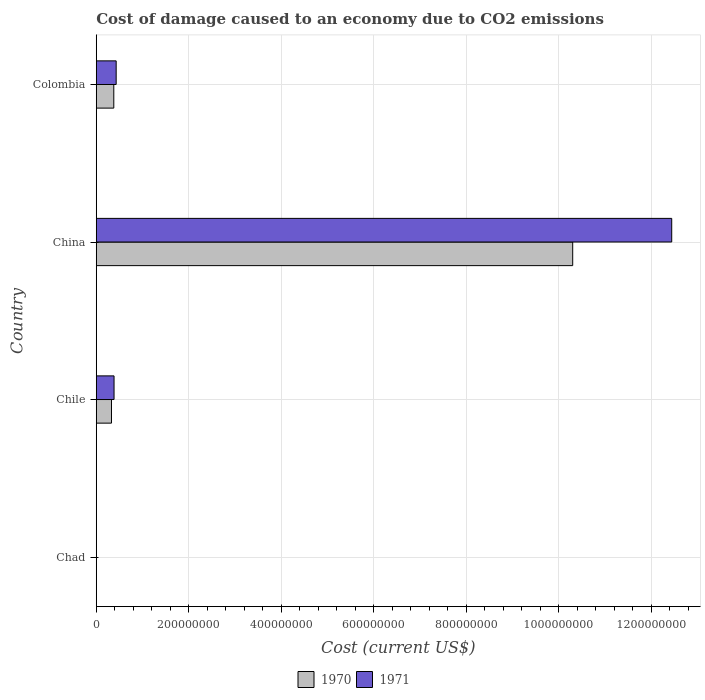How many bars are there on the 2nd tick from the bottom?
Provide a short and direct response. 2. What is the label of the 2nd group of bars from the top?
Make the answer very short. China. In how many cases, is the number of bars for a given country not equal to the number of legend labels?
Your answer should be very brief. 0. What is the cost of damage caused due to CO2 emissisons in 1971 in China?
Provide a succinct answer. 1.24e+09. Across all countries, what is the maximum cost of damage caused due to CO2 emissisons in 1970?
Your response must be concise. 1.03e+09. Across all countries, what is the minimum cost of damage caused due to CO2 emissisons in 1971?
Offer a terse response. 2.13e+05. In which country was the cost of damage caused due to CO2 emissisons in 1971 minimum?
Give a very brief answer. Chad. What is the total cost of damage caused due to CO2 emissisons in 1970 in the graph?
Your answer should be very brief. 1.10e+09. What is the difference between the cost of damage caused due to CO2 emissisons in 1971 in Chad and that in Chile?
Your response must be concise. -3.82e+07. What is the difference between the cost of damage caused due to CO2 emissisons in 1970 in Colombia and the cost of damage caused due to CO2 emissisons in 1971 in China?
Ensure brevity in your answer.  -1.21e+09. What is the average cost of damage caused due to CO2 emissisons in 1970 per country?
Provide a succinct answer. 2.75e+08. What is the difference between the cost of damage caused due to CO2 emissisons in 1970 and cost of damage caused due to CO2 emissisons in 1971 in Chile?
Give a very brief answer. -5.53e+06. In how many countries, is the cost of damage caused due to CO2 emissisons in 1971 greater than 40000000 US$?
Ensure brevity in your answer.  2. What is the ratio of the cost of damage caused due to CO2 emissisons in 1971 in Chad to that in Colombia?
Ensure brevity in your answer.  0. Is the cost of damage caused due to CO2 emissisons in 1970 in Chile less than that in Colombia?
Ensure brevity in your answer.  Yes. Is the difference between the cost of damage caused due to CO2 emissisons in 1970 in China and Colombia greater than the difference between the cost of damage caused due to CO2 emissisons in 1971 in China and Colombia?
Ensure brevity in your answer.  No. What is the difference between the highest and the second highest cost of damage caused due to CO2 emissisons in 1970?
Your answer should be compact. 9.92e+08. What is the difference between the highest and the lowest cost of damage caused due to CO2 emissisons in 1970?
Offer a very short reply. 1.03e+09. What does the 2nd bar from the top in Colombia represents?
Offer a very short reply. 1970. What does the 2nd bar from the bottom in China represents?
Offer a very short reply. 1971. How many countries are there in the graph?
Provide a short and direct response. 4. What is the difference between two consecutive major ticks on the X-axis?
Your response must be concise. 2.00e+08. Does the graph contain any zero values?
Ensure brevity in your answer.  No. Does the graph contain grids?
Keep it short and to the point. Yes. How many legend labels are there?
Ensure brevity in your answer.  2. What is the title of the graph?
Offer a terse response. Cost of damage caused to an economy due to CO2 emissions. What is the label or title of the X-axis?
Provide a short and direct response. Cost (current US$). What is the Cost (current US$) in 1970 in Chad?
Your answer should be very brief. 1.66e+05. What is the Cost (current US$) of 1971 in Chad?
Your answer should be very brief. 2.13e+05. What is the Cost (current US$) in 1970 in Chile?
Make the answer very short. 3.29e+07. What is the Cost (current US$) in 1971 in Chile?
Your answer should be very brief. 3.84e+07. What is the Cost (current US$) of 1970 in China?
Offer a very short reply. 1.03e+09. What is the Cost (current US$) in 1971 in China?
Make the answer very short. 1.24e+09. What is the Cost (current US$) in 1970 in Colombia?
Your response must be concise. 3.79e+07. What is the Cost (current US$) in 1971 in Colombia?
Give a very brief answer. 4.30e+07. Across all countries, what is the maximum Cost (current US$) of 1970?
Your response must be concise. 1.03e+09. Across all countries, what is the maximum Cost (current US$) in 1971?
Provide a short and direct response. 1.24e+09. Across all countries, what is the minimum Cost (current US$) in 1970?
Your response must be concise. 1.66e+05. Across all countries, what is the minimum Cost (current US$) of 1971?
Make the answer very short. 2.13e+05. What is the total Cost (current US$) of 1970 in the graph?
Your answer should be compact. 1.10e+09. What is the total Cost (current US$) of 1971 in the graph?
Your answer should be compact. 1.33e+09. What is the difference between the Cost (current US$) in 1970 in Chad and that in Chile?
Provide a short and direct response. -3.28e+07. What is the difference between the Cost (current US$) of 1971 in Chad and that in Chile?
Give a very brief answer. -3.82e+07. What is the difference between the Cost (current US$) in 1970 in Chad and that in China?
Your answer should be very brief. -1.03e+09. What is the difference between the Cost (current US$) of 1971 in Chad and that in China?
Offer a very short reply. -1.24e+09. What is the difference between the Cost (current US$) of 1970 in Chad and that in Colombia?
Ensure brevity in your answer.  -3.77e+07. What is the difference between the Cost (current US$) in 1971 in Chad and that in Colombia?
Ensure brevity in your answer.  -4.28e+07. What is the difference between the Cost (current US$) in 1970 in Chile and that in China?
Your answer should be very brief. -9.97e+08. What is the difference between the Cost (current US$) of 1971 in Chile and that in China?
Your answer should be very brief. -1.21e+09. What is the difference between the Cost (current US$) of 1970 in Chile and that in Colombia?
Offer a very short reply. -4.99e+06. What is the difference between the Cost (current US$) of 1971 in Chile and that in Colombia?
Give a very brief answer. -4.58e+06. What is the difference between the Cost (current US$) of 1970 in China and that in Colombia?
Keep it short and to the point. 9.92e+08. What is the difference between the Cost (current US$) in 1971 in China and that in Colombia?
Ensure brevity in your answer.  1.20e+09. What is the difference between the Cost (current US$) of 1970 in Chad and the Cost (current US$) of 1971 in Chile?
Keep it short and to the point. -3.83e+07. What is the difference between the Cost (current US$) in 1970 in Chad and the Cost (current US$) in 1971 in China?
Ensure brevity in your answer.  -1.24e+09. What is the difference between the Cost (current US$) of 1970 in Chad and the Cost (current US$) of 1971 in Colombia?
Your response must be concise. -4.29e+07. What is the difference between the Cost (current US$) of 1970 in Chile and the Cost (current US$) of 1971 in China?
Provide a short and direct response. -1.21e+09. What is the difference between the Cost (current US$) of 1970 in Chile and the Cost (current US$) of 1971 in Colombia?
Provide a succinct answer. -1.01e+07. What is the difference between the Cost (current US$) in 1970 in China and the Cost (current US$) in 1971 in Colombia?
Provide a succinct answer. 9.87e+08. What is the average Cost (current US$) of 1970 per country?
Keep it short and to the point. 2.75e+08. What is the average Cost (current US$) of 1971 per country?
Keep it short and to the point. 3.31e+08. What is the difference between the Cost (current US$) of 1970 and Cost (current US$) of 1971 in Chad?
Your answer should be compact. -4.69e+04. What is the difference between the Cost (current US$) of 1970 and Cost (current US$) of 1971 in Chile?
Your response must be concise. -5.53e+06. What is the difference between the Cost (current US$) in 1970 and Cost (current US$) in 1971 in China?
Make the answer very short. -2.14e+08. What is the difference between the Cost (current US$) of 1970 and Cost (current US$) of 1971 in Colombia?
Your answer should be compact. -5.12e+06. What is the ratio of the Cost (current US$) of 1970 in Chad to that in Chile?
Your answer should be compact. 0.01. What is the ratio of the Cost (current US$) of 1971 in Chad to that in Chile?
Your response must be concise. 0.01. What is the ratio of the Cost (current US$) of 1970 in Chad to that in Colombia?
Keep it short and to the point. 0. What is the ratio of the Cost (current US$) of 1971 in Chad to that in Colombia?
Keep it short and to the point. 0.01. What is the ratio of the Cost (current US$) of 1970 in Chile to that in China?
Your response must be concise. 0.03. What is the ratio of the Cost (current US$) in 1971 in Chile to that in China?
Provide a succinct answer. 0.03. What is the ratio of the Cost (current US$) in 1970 in Chile to that in Colombia?
Offer a terse response. 0.87. What is the ratio of the Cost (current US$) in 1971 in Chile to that in Colombia?
Ensure brevity in your answer.  0.89. What is the ratio of the Cost (current US$) in 1970 in China to that in Colombia?
Ensure brevity in your answer.  27.17. What is the ratio of the Cost (current US$) in 1971 in China to that in Colombia?
Your answer should be very brief. 28.91. What is the difference between the highest and the second highest Cost (current US$) of 1970?
Your response must be concise. 9.92e+08. What is the difference between the highest and the second highest Cost (current US$) in 1971?
Your response must be concise. 1.20e+09. What is the difference between the highest and the lowest Cost (current US$) in 1970?
Your answer should be compact. 1.03e+09. What is the difference between the highest and the lowest Cost (current US$) in 1971?
Keep it short and to the point. 1.24e+09. 